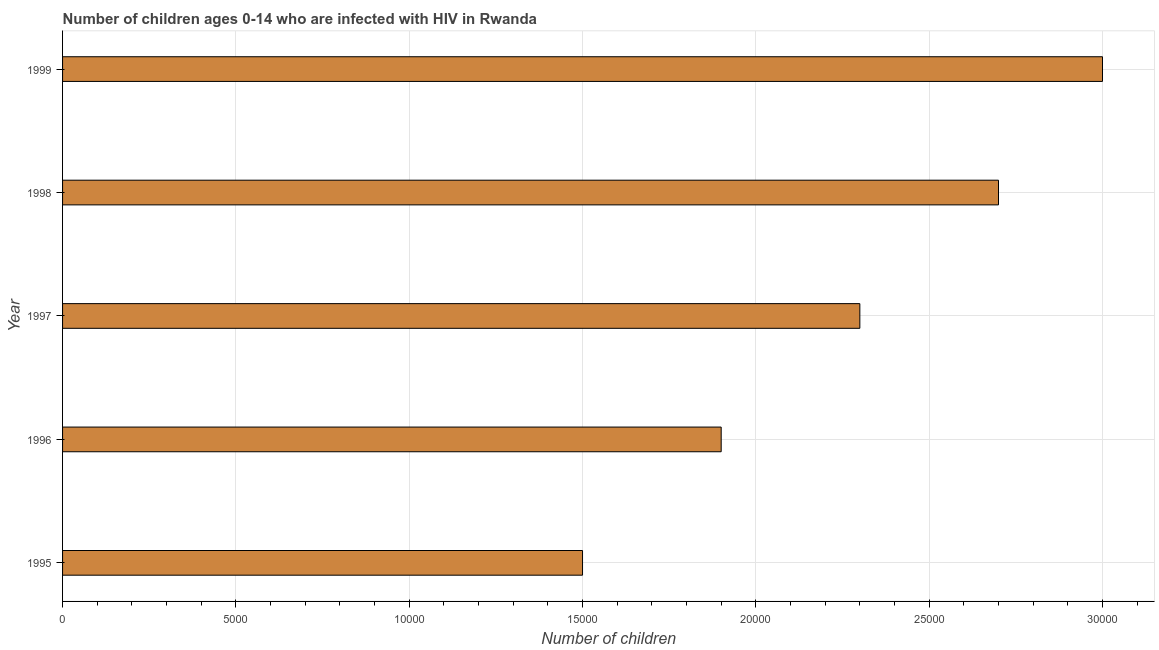Does the graph contain any zero values?
Provide a succinct answer. No. What is the title of the graph?
Provide a short and direct response. Number of children ages 0-14 who are infected with HIV in Rwanda. What is the label or title of the X-axis?
Give a very brief answer. Number of children. What is the label or title of the Y-axis?
Keep it short and to the point. Year. What is the number of children living with hiv in 1997?
Offer a very short reply. 2.30e+04. Across all years, what is the maximum number of children living with hiv?
Provide a succinct answer. 3.00e+04. Across all years, what is the minimum number of children living with hiv?
Keep it short and to the point. 1.50e+04. In which year was the number of children living with hiv maximum?
Provide a succinct answer. 1999. In which year was the number of children living with hiv minimum?
Your response must be concise. 1995. What is the sum of the number of children living with hiv?
Your answer should be very brief. 1.14e+05. What is the difference between the number of children living with hiv in 1995 and 1997?
Provide a succinct answer. -8000. What is the average number of children living with hiv per year?
Your answer should be very brief. 2.28e+04. What is the median number of children living with hiv?
Offer a very short reply. 2.30e+04. What is the ratio of the number of children living with hiv in 1995 to that in 1997?
Keep it short and to the point. 0.65. Is the number of children living with hiv in 1995 less than that in 1996?
Ensure brevity in your answer.  Yes. Is the difference between the number of children living with hiv in 1998 and 1999 greater than the difference between any two years?
Provide a short and direct response. No. What is the difference between the highest and the second highest number of children living with hiv?
Provide a succinct answer. 3000. Is the sum of the number of children living with hiv in 1997 and 1999 greater than the maximum number of children living with hiv across all years?
Keep it short and to the point. Yes. What is the difference between the highest and the lowest number of children living with hiv?
Your response must be concise. 1.50e+04. In how many years, is the number of children living with hiv greater than the average number of children living with hiv taken over all years?
Make the answer very short. 3. How many bars are there?
Keep it short and to the point. 5. Are all the bars in the graph horizontal?
Offer a very short reply. Yes. Are the values on the major ticks of X-axis written in scientific E-notation?
Your response must be concise. No. What is the Number of children in 1995?
Make the answer very short. 1.50e+04. What is the Number of children of 1996?
Provide a succinct answer. 1.90e+04. What is the Number of children of 1997?
Offer a terse response. 2.30e+04. What is the Number of children in 1998?
Give a very brief answer. 2.70e+04. What is the difference between the Number of children in 1995 and 1996?
Make the answer very short. -4000. What is the difference between the Number of children in 1995 and 1997?
Make the answer very short. -8000. What is the difference between the Number of children in 1995 and 1998?
Your response must be concise. -1.20e+04. What is the difference between the Number of children in 1995 and 1999?
Offer a terse response. -1.50e+04. What is the difference between the Number of children in 1996 and 1997?
Provide a succinct answer. -4000. What is the difference between the Number of children in 1996 and 1998?
Provide a short and direct response. -8000. What is the difference between the Number of children in 1996 and 1999?
Your response must be concise. -1.10e+04. What is the difference between the Number of children in 1997 and 1998?
Your answer should be very brief. -4000. What is the difference between the Number of children in 1997 and 1999?
Keep it short and to the point. -7000. What is the difference between the Number of children in 1998 and 1999?
Your response must be concise. -3000. What is the ratio of the Number of children in 1995 to that in 1996?
Offer a very short reply. 0.79. What is the ratio of the Number of children in 1995 to that in 1997?
Your answer should be very brief. 0.65. What is the ratio of the Number of children in 1995 to that in 1998?
Offer a terse response. 0.56. What is the ratio of the Number of children in 1995 to that in 1999?
Provide a succinct answer. 0.5. What is the ratio of the Number of children in 1996 to that in 1997?
Your response must be concise. 0.83. What is the ratio of the Number of children in 1996 to that in 1998?
Provide a succinct answer. 0.7. What is the ratio of the Number of children in 1996 to that in 1999?
Make the answer very short. 0.63. What is the ratio of the Number of children in 1997 to that in 1998?
Your answer should be very brief. 0.85. What is the ratio of the Number of children in 1997 to that in 1999?
Give a very brief answer. 0.77. What is the ratio of the Number of children in 1998 to that in 1999?
Your answer should be very brief. 0.9. 